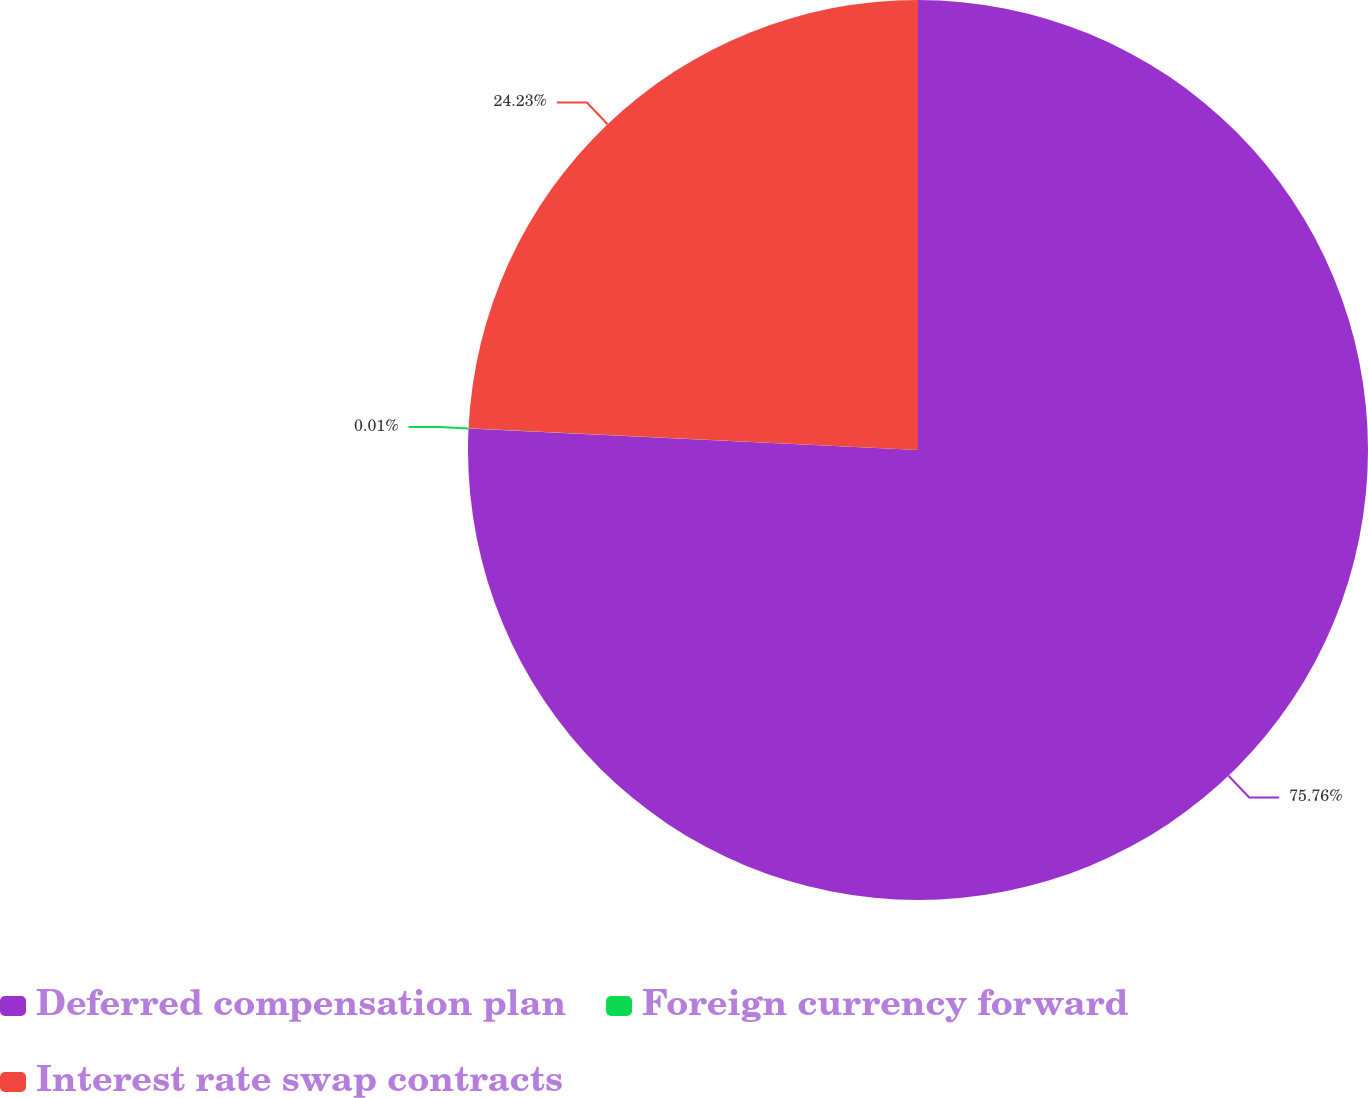<chart> <loc_0><loc_0><loc_500><loc_500><pie_chart><fcel>Deferred compensation plan<fcel>Foreign currency forward<fcel>Interest rate swap contracts<nl><fcel>75.76%<fcel>0.01%<fcel>24.23%<nl></chart> 